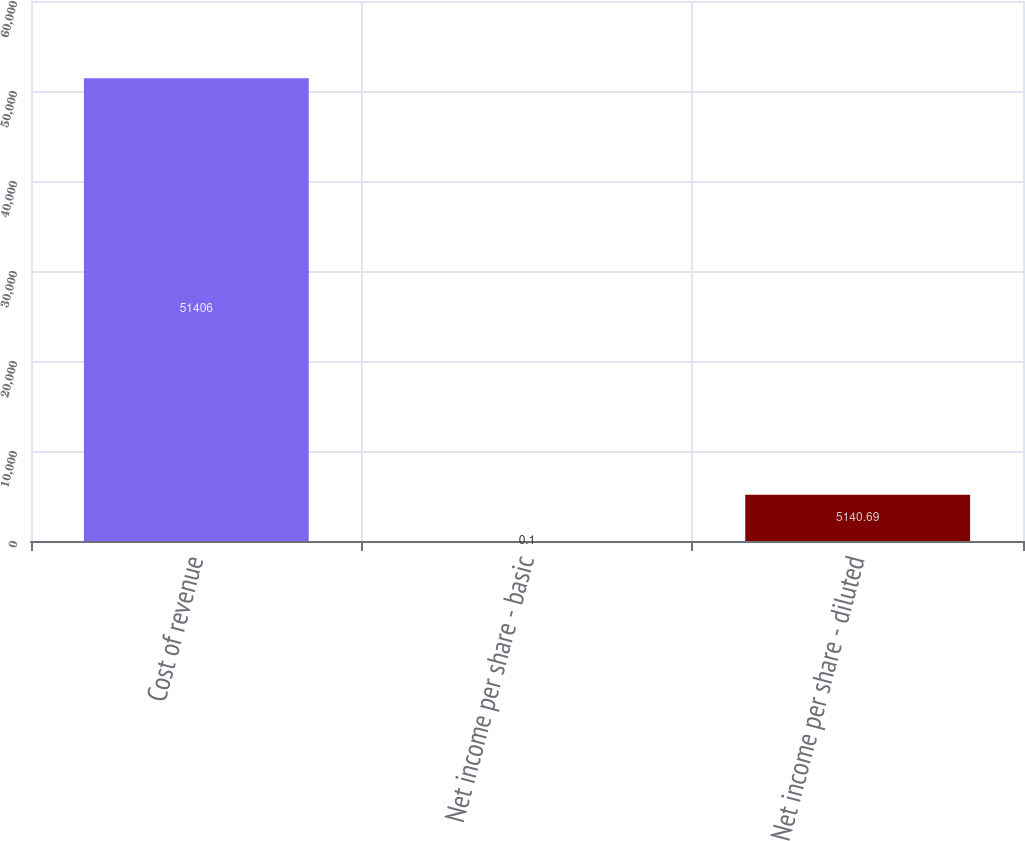<chart> <loc_0><loc_0><loc_500><loc_500><bar_chart><fcel>Cost of revenue<fcel>Net income per share - basic<fcel>Net income per share - diluted<nl><fcel>51406<fcel>0.1<fcel>5140.69<nl></chart> 